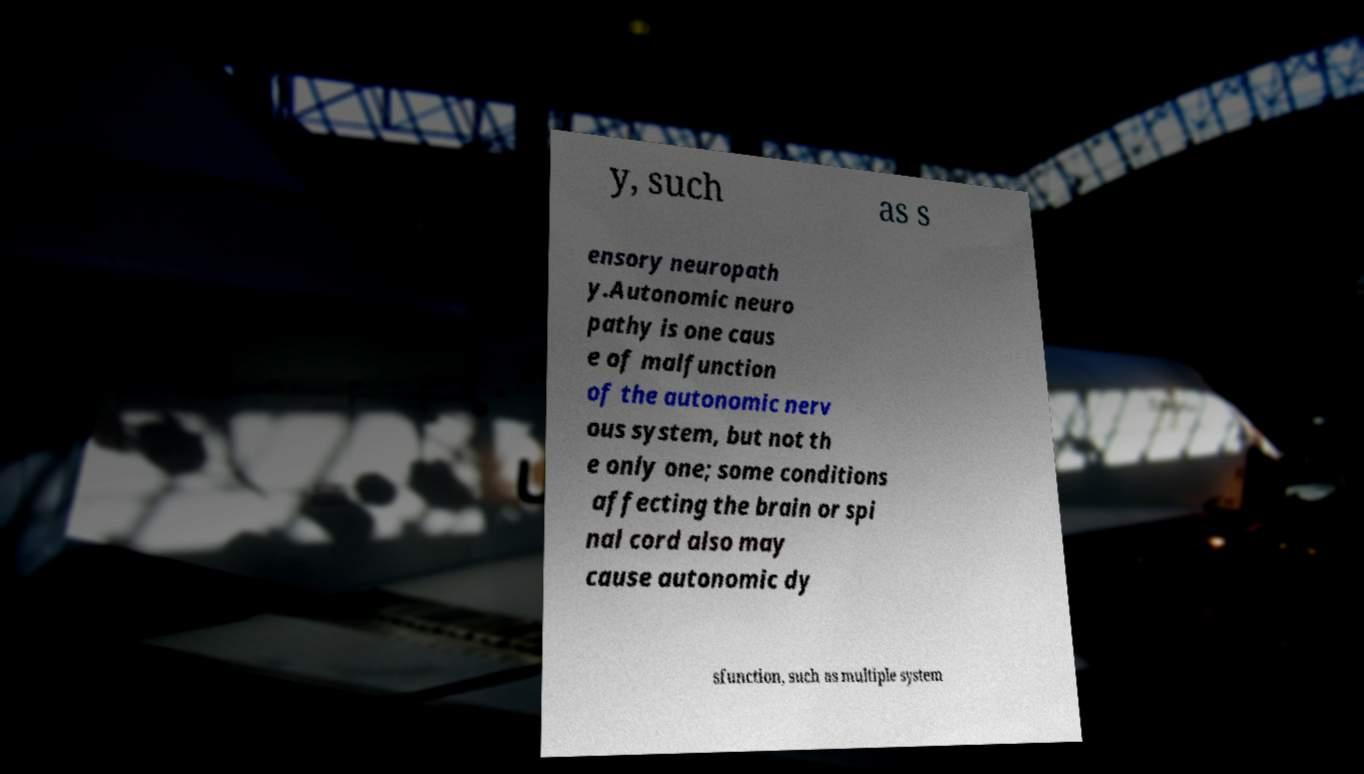For documentation purposes, I need the text within this image transcribed. Could you provide that? y, such as s ensory neuropath y.Autonomic neuro pathy is one caus e of malfunction of the autonomic nerv ous system, but not th e only one; some conditions affecting the brain or spi nal cord also may cause autonomic dy sfunction, such as multiple system 